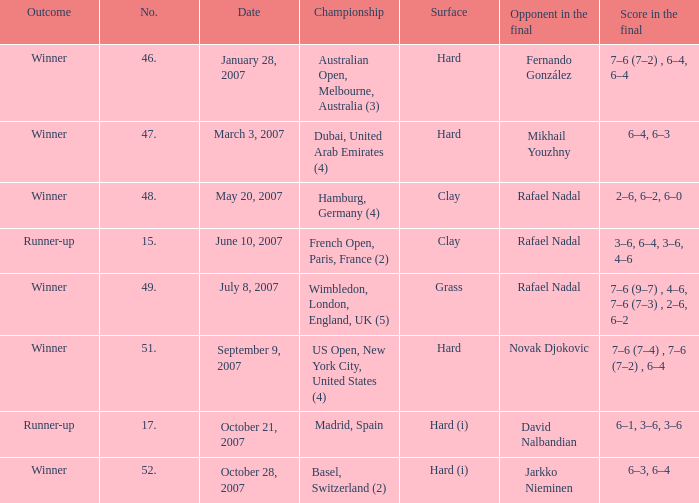When the  score in the final is 3–6, 6–4, 3–6, 4–6, who are all the opponents in the final? Rafael Nadal. 